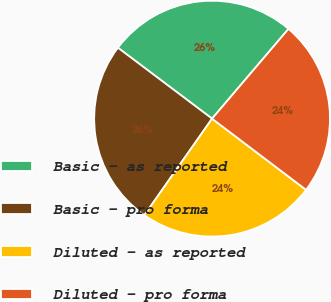<chart> <loc_0><loc_0><loc_500><loc_500><pie_chart><fcel>Basic - as reported<fcel>Basic - pro forma<fcel>Diluted - as reported<fcel>Diluted - pro forma<nl><fcel>25.95%<fcel>25.54%<fcel>24.42%<fcel>24.09%<nl></chart> 